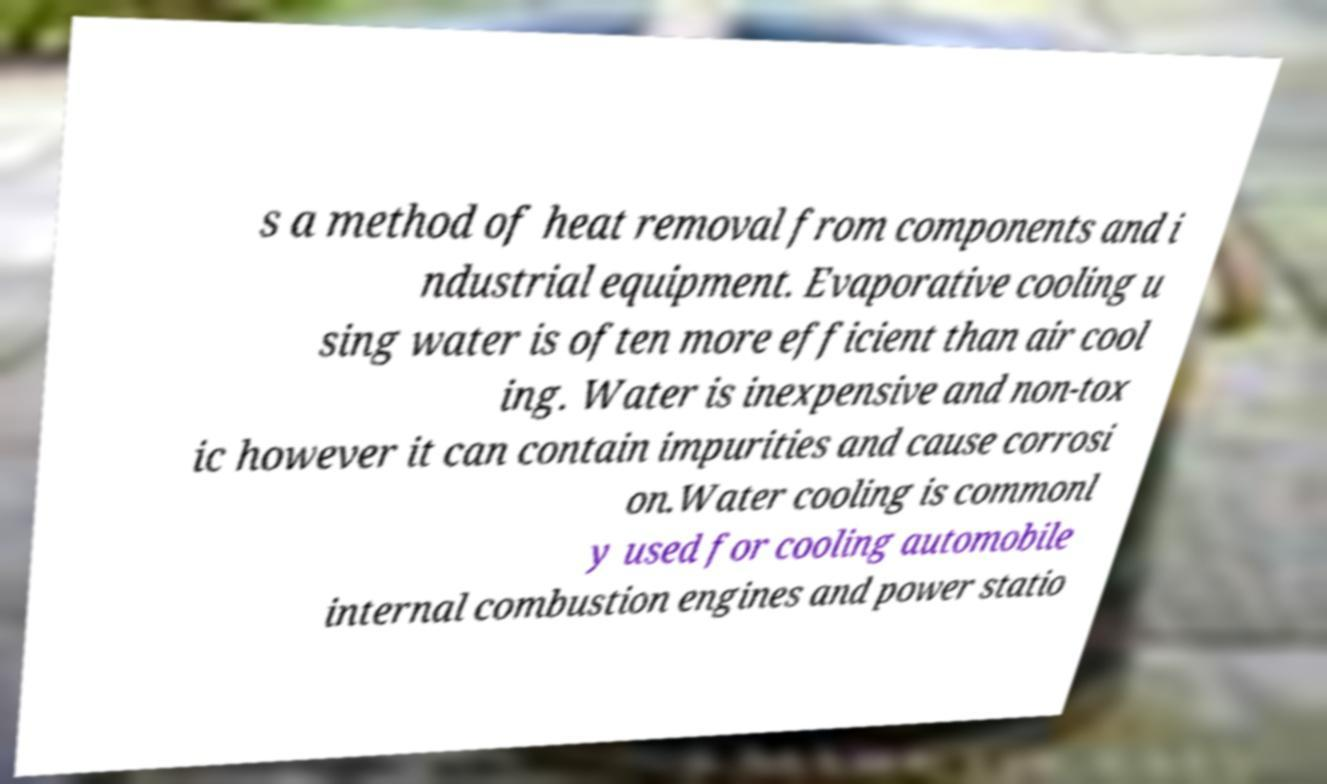What messages or text are displayed in this image? I need them in a readable, typed format. s a method of heat removal from components and i ndustrial equipment. Evaporative cooling u sing water is often more efficient than air cool ing. Water is inexpensive and non-tox ic however it can contain impurities and cause corrosi on.Water cooling is commonl y used for cooling automobile internal combustion engines and power statio 